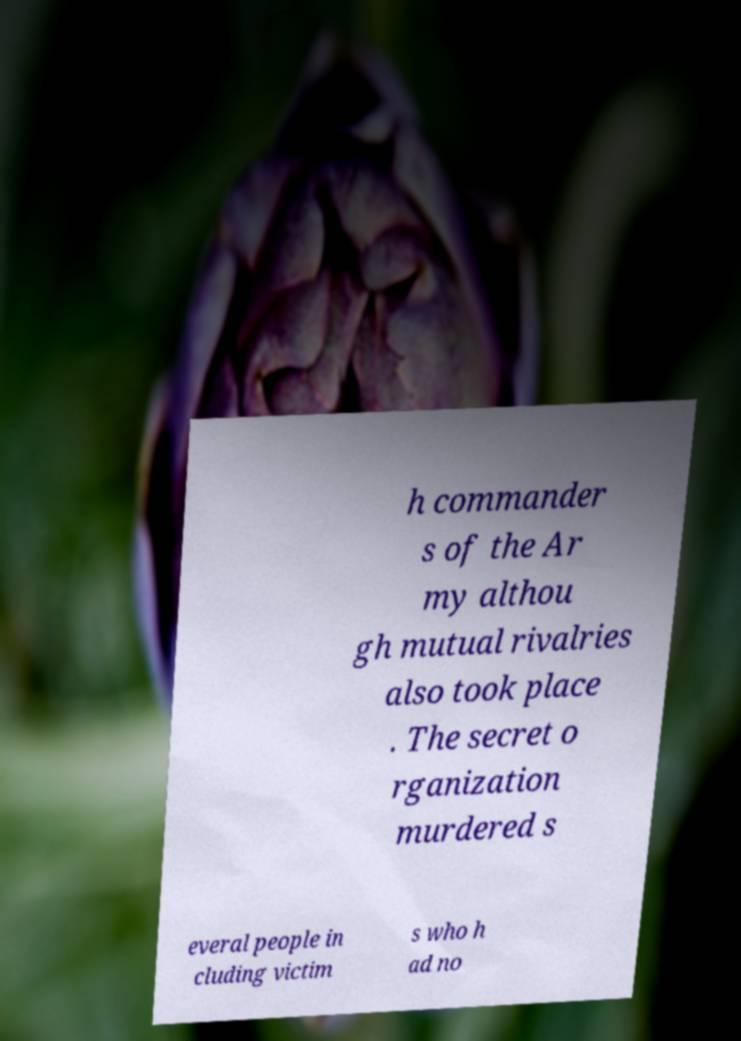What messages or text are displayed in this image? I need them in a readable, typed format. h commander s of the Ar my althou gh mutual rivalries also took place . The secret o rganization murdered s everal people in cluding victim s who h ad no 